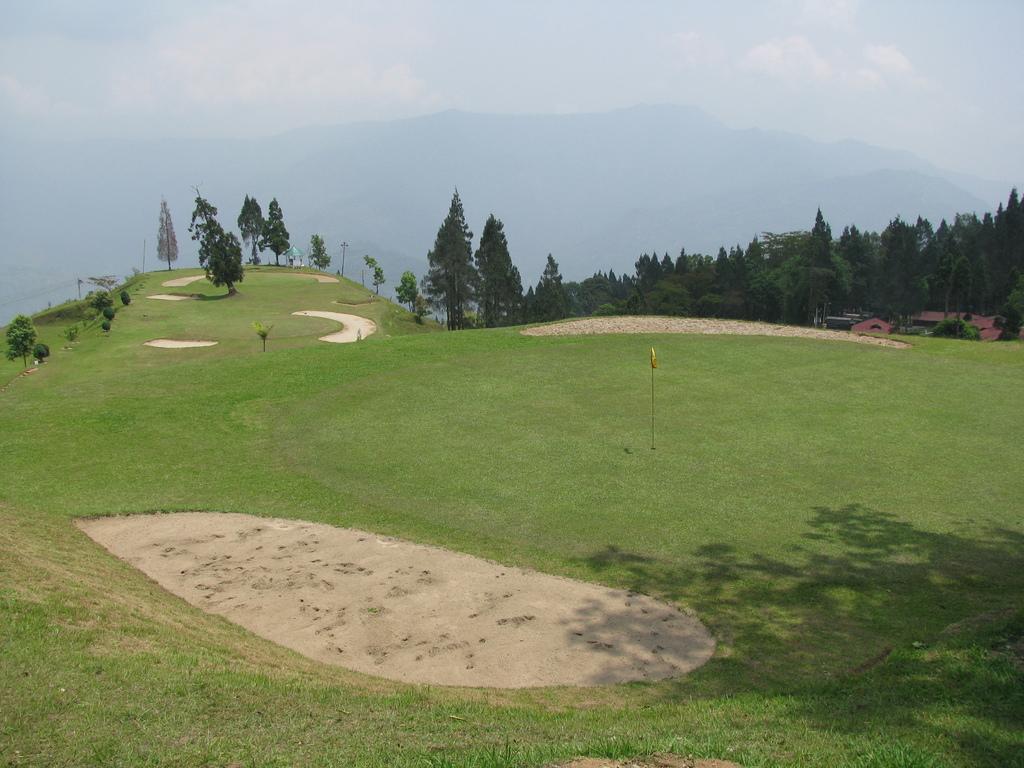Can you describe this image briefly? In the picture there is a ground, there are trees, there are houses, there are mountains, there is the sky. 